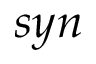Convert formula to latex. <formula><loc_0><loc_0><loc_500><loc_500>s y n</formula> 